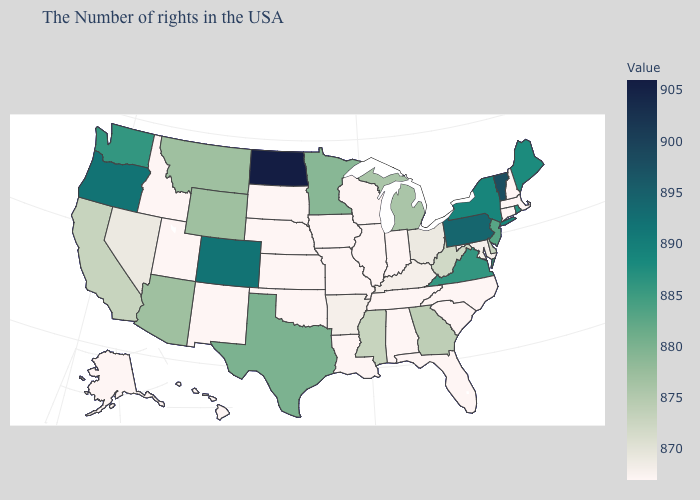Among the states that border Illinois , does Wisconsin have the highest value?
Write a very short answer. No. Which states have the lowest value in the West?
Write a very short answer. New Mexico, Utah, Idaho, Alaska, Hawaii. Which states hav the highest value in the Northeast?
Write a very short answer. Vermont. Is the legend a continuous bar?
Concise answer only. Yes. 